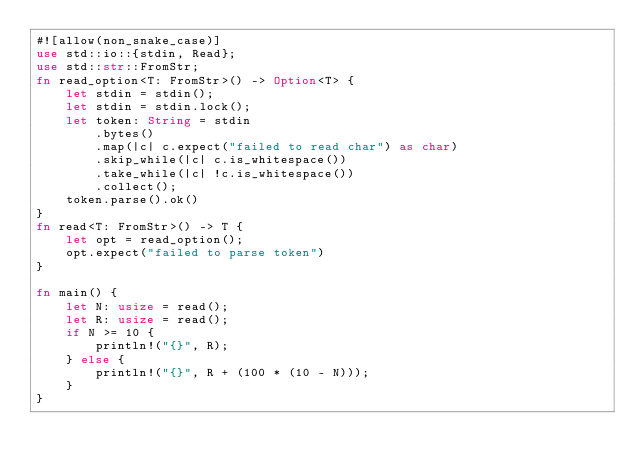Convert code to text. <code><loc_0><loc_0><loc_500><loc_500><_Rust_>#![allow(non_snake_case)]
use std::io::{stdin, Read};
use std::str::FromStr;
fn read_option<T: FromStr>() -> Option<T> {
    let stdin = stdin();
    let stdin = stdin.lock();
    let token: String = stdin
        .bytes()
        .map(|c| c.expect("failed to read char") as char)
        .skip_while(|c| c.is_whitespace())
        .take_while(|c| !c.is_whitespace())
        .collect();
    token.parse().ok()
}
fn read<T: FromStr>() -> T {
    let opt = read_option();
    opt.expect("failed to parse token")
}

fn main() {
    let N: usize = read();
    let R: usize = read();
    if N >= 10 {
        println!("{}", R);
    } else {
        println!("{}", R + (100 * (10 - N)));
    }
}
</code> 